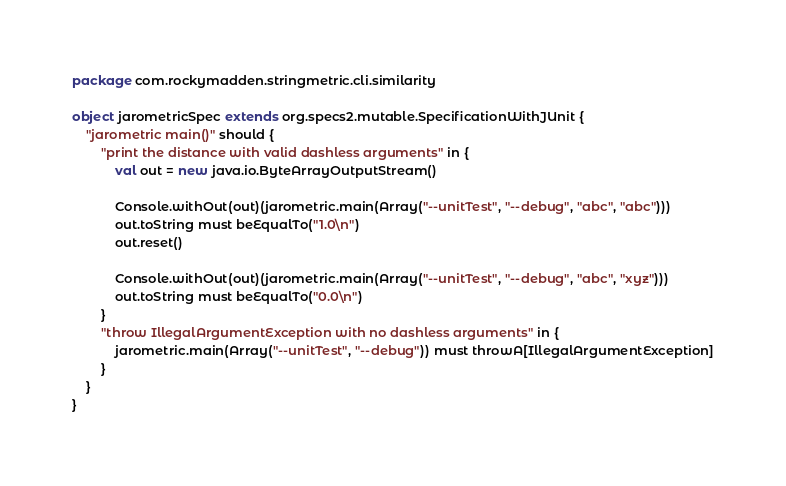Convert code to text. <code><loc_0><loc_0><loc_500><loc_500><_Scala_>package com.rockymadden.stringmetric.cli.similarity

object jarometricSpec extends org.specs2.mutable.SpecificationWithJUnit {
	"jarometric main()" should {
		"print the distance with valid dashless arguments" in {
			val out = new java.io.ByteArrayOutputStream()

			Console.withOut(out)(jarometric.main(Array("--unitTest", "--debug", "abc", "abc")))
			out.toString must beEqualTo("1.0\n")
			out.reset()

			Console.withOut(out)(jarometric.main(Array("--unitTest", "--debug", "abc", "xyz")))
			out.toString must beEqualTo("0.0\n")
		}
		"throw IllegalArgumentException with no dashless arguments" in {
			jarometric.main(Array("--unitTest", "--debug")) must throwA[IllegalArgumentException]
		}
	}
}
</code> 